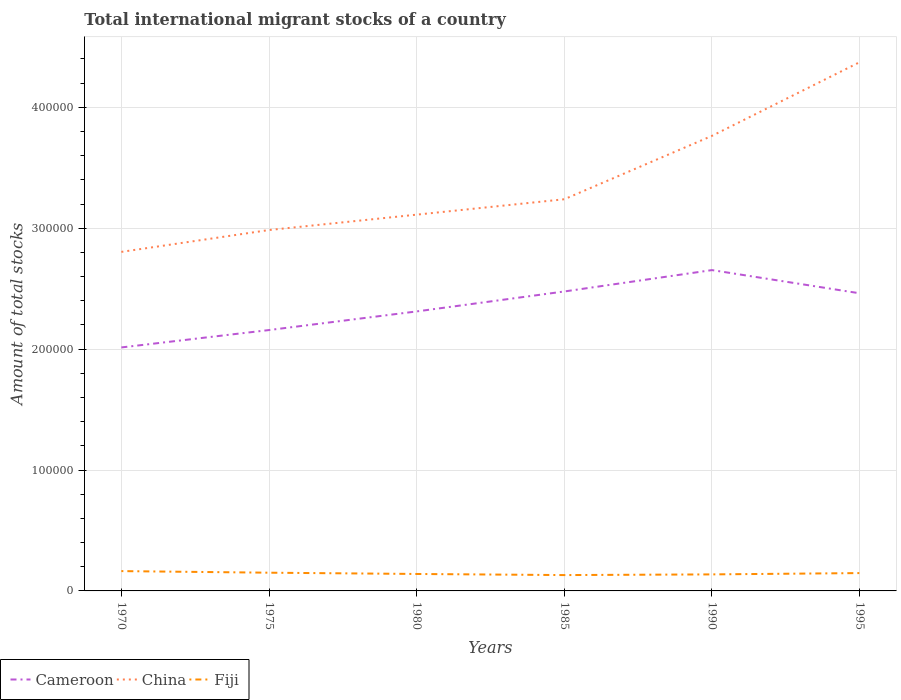How many different coloured lines are there?
Ensure brevity in your answer.  3. Across all years, what is the maximum amount of total stocks in in Cameroon?
Keep it short and to the point. 2.01e+05. In which year was the amount of total stocks in in Fiji maximum?
Your answer should be compact. 1985. What is the total amount of total stocks in in Cameroon in the graph?
Offer a terse response. 1490. What is the difference between the highest and the second highest amount of total stocks in in China?
Your answer should be compact. 1.57e+05. What is the difference between the highest and the lowest amount of total stocks in in Cameroon?
Give a very brief answer. 3. How many lines are there?
Your response must be concise. 3. How many years are there in the graph?
Your answer should be very brief. 6. Does the graph contain grids?
Make the answer very short. Yes. How are the legend labels stacked?
Provide a short and direct response. Horizontal. What is the title of the graph?
Give a very brief answer. Total international migrant stocks of a country. What is the label or title of the Y-axis?
Provide a succinct answer. Amount of total stocks. What is the Amount of total stocks of Cameroon in 1970?
Offer a very short reply. 2.01e+05. What is the Amount of total stocks of China in 1970?
Provide a short and direct response. 2.80e+05. What is the Amount of total stocks of Fiji in 1970?
Your answer should be compact. 1.64e+04. What is the Amount of total stocks of Cameroon in 1975?
Your response must be concise. 2.16e+05. What is the Amount of total stocks in China in 1975?
Give a very brief answer. 2.98e+05. What is the Amount of total stocks of Fiji in 1975?
Give a very brief answer. 1.51e+04. What is the Amount of total stocks of Cameroon in 1980?
Ensure brevity in your answer.  2.31e+05. What is the Amount of total stocks of China in 1980?
Offer a very short reply. 3.11e+05. What is the Amount of total stocks of Fiji in 1980?
Provide a short and direct response. 1.40e+04. What is the Amount of total stocks in Cameroon in 1985?
Your answer should be compact. 2.48e+05. What is the Amount of total stocks in China in 1985?
Your answer should be compact. 3.24e+05. What is the Amount of total stocks of Fiji in 1985?
Give a very brief answer. 1.31e+04. What is the Amount of total stocks of Cameroon in 1990?
Your answer should be very brief. 2.65e+05. What is the Amount of total stocks of China in 1990?
Provide a succinct answer. 3.76e+05. What is the Amount of total stocks in Fiji in 1990?
Ensure brevity in your answer.  1.37e+04. What is the Amount of total stocks of Cameroon in 1995?
Offer a very short reply. 2.46e+05. What is the Amount of total stocks in China in 1995?
Offer a terse response. 4.37e+05. What is the Amount of total stocks in Fiji in 1995?
Ensure brevity in your answer.  1.48e+04. Across all years, what is the maximum Amount of total stocks in Cameroon?
Ensure brevity in your answer.  2.65e+05. Across all years, what is the maximum Amount of total stocks in China?
Provide a short and direct response. 4.37e+05. Across all years, what is the maximum Amount of total stocks of Fiji?
Your answer should be compact. 1.64e+04. Across all years, what is the minimum Amount of total stocks in Cameroon?
Provide a succinct answer. 2.01e+05. Across all years, what is the minimum Amount of total stocks of China?
Give a very brief answer. 2.80e+05. Across all years, what is the minimum Amount of total stocks of Fiji?
Keep it short and to the point. 1.31e+04. What is the total Amount of total stocks in Cameroon in the graph?
Give a very brief answer. 1.41e+06. What is the total Amount of total stocks of China in the graph?
Ensure brevity in your answer.  2.03e+06. What is the total Amount of total stocks of Fiji in the graph?
Ensure brevity in your answer.  8.70e+04. What is the difference between the Amount of total stocks of Cameroon in 1970 and that in 1975?
Your response must be concise. -1.44e+04. What is the difference between the Amount of total stocks in China in 1970 and that in 1975?
Provide a short and direct response. -1.81e+04. What is the difference between the Amount of total stocks of Fiji in 1970 and that in 1975?
Offer a terse response. 1323. What is the difference between the Amount of total stocks of Cameroon in 1970 and that in 1980?
Your answer should be very brief. -2.98e+04. What is the difference between the Amount of total stocks of China in 1970 and that in 1980?
Provide a short and direct response. -3.08e+04. What is the difference between the Amount of total stocks in Fiji in 1970 and that in 1980?
Your response must be concise. 2369. What is the difference between the Amount of total stocks in Cameroon in 1970 and that in 1985?
Keep it short and to the point. -4.63e+04. What is the difference between the Amount of total stocks in China in 1970 and that in 1985?
Give a very brief answer. -4.35e+04. What is the difference between the Amount of total stocks of Fiji in 1970 and that in 1985?
Your response must be concise. 3291. What is the difference between the Amount of total stocks of Cameroon in 1970 and that in 1990?
Your response must be concise. -6.40e+04. What is the difference between the Amount of total stocks of China in 1970 and that in 1990?
Your response must be concise. -9.60e+04. What is the difference between the Amount of total stocks in Fiji in 1970 and that in 1990?
Give a very brief answer. 2723. What is the difference between the Amount of total stocks of Cameroon in 1970 and that in 1995?
Provide a succinct answer. -4.48e+04. What is the difference between the Amount of total stocks of China in 1970 and that in 1995?
Your answer should be very brief. -1.57e+05. What is the difference between the Amount of total stocks in Fiji in 1970 and that in 1995?
Your answer should be compact. 1642. What is the difference between the Amount of total stocks of Cameroon in 1975 and that in 1980?
Give a very brief answer. -1.54e+04. What is the difference between the Amount of total stocks in China in 1975 and that in 1980?
Offer a terse response. -1.27e+04. What is the difference between the Amount of total stocks of Fiji in 1975 and that in 1980?
Make the answer very short. 1046. What is the difference between the Amount of total stocks in Cameroon in 1975 and that in 1985?
Provide a succinct answer. -3.19e+04. What is the difference between the Amount of total stocks of China in 1975 and that in 1985?
Offer a terse response. -2.55e+04. What is the difference between the Amount of total stocks in Fiji in 1975 and that in 1985?
Your response must be concise. 1968. What is the difference between the Amount of total stocks in Cameroon in 1975 and that in 1990?
Your answer should be compact. -4.96e+04. What is the difference between the Amount of total stocks of China in 1975 and that in 1990?
Your answer should be very brief. -7.79e+04. What is the difference between the Amount of total stocks in Fiji in 1975 and that in 1990?
Provide a short and direct response. 1400. What is the difference between the Amount of total stocks in Cameroon in 1975 and that in 1995?
Offer a terse response. -3.04e+04. What is the difference between the Amount of total stocks of China in 1975 and that in 1995?
Your answer should be very brief. -1.39e+05. What is the difference between the Amount of total stocks of Fiji in 1975 and that in 1995?
Offer a very short reply. 319. What is the difference between the Amount of total stocks of Cameroon in 1980 and that in 1985?
Provide a short and direct response. -1.65e+04. What is the difference between the Amount of total stocks in China in 1980 and that in 1985?
Offer a terse response. -1.27e+04. What is the difference between the Amount of total stocks in Fiji in 1980 and that in 1985?
Ensure brevity in your answer.  922. What is the difference between the Amount of total stocks in Cameroon in 1980 and that in 1990?
Provide a succinct answer. -3.42e+04. What is the difference between the Amount of total stocks in China in 1980 and that in 1990?
Provide a short and direct response. -6.52e+04. What is the difference between the Amount of total stocks in Fiji in 1980 and that in 1990?
Your response must be concise. 354. What is the difference between the Amount of total stocks of Cameroon in 1980 and that in 1995?
Offer a terse response. -1.50e+04. What is the difference between the Amount of total stocks of China in 1980 and that in 1995?
Provide a short and direct response. -1.26e+05. What is the difference between the Amount of total stocks of Fiji in 1980 and that in 1995?
Offer a very short reply. -727. What is the difference between the Amount of total stocks of Cameroon in 1985 and that in 1990?
Your answer should be compact. -1.77e+04. What is the difference between the Amount of total stocks of China in 1985 and that in 1990?
Your response must be concise. -5.24e+04. What is the difference between the Amount of total stocks in Fiji in 1985 and that in 1990?
Give a very brief answer. -568. What is the difference between the Amount of total stocks of Cameroon in 1985 and that in 1995?
Your answer should be compact. 1490. What is the difference between the Amount of total stocks in China in 1985 and that in 1995?
Offer a very short reply. -1.13e+05. What is the difference between the Amount of total stocks of Fiji in 1985 and that in 1995?
Your answer should be very brief. -1649. What is the difference between the Amount of total stocks in Cameroon in 1990 and that in 1995?
Your response must be concise. 1.92e+04. What is the difference between the Amount of total stocks of China in 1990 and that in 1995?
Provide a succinct answer. -6.09e+04. What is the difference between the Amount of total stocks in Fiji in 1990 and that in 1995?
Offer a very short reply. -1081. What is the difference between the Amount of total stocks in Cameroon in 1970 and the Amount of total stocks in China in 1975?
Your answer should be very brief. -9.71e+04. What is the difference between the Amount of total stocks of Cameroon in 1970 and the Amount of total stocks of Fiji in 1975?
Your response must be concise. 1.86e+05. What is the difference between the Amount of total stocks in China in 1970 and the Amount of total stocks in Fiji in 1975?
Your answer should be compact. 2.65e+05. What is the difference between the Amount of total stocks in Cameroon in 1970 and the Amount of total stocks in China in 1980?
Your answer should be compact. -1.10e+05. What is the difference between the Amount of total stocks of Cameroon in 1970 and the Amount of total stocks of Fiji in 1980?
Your answer should be compact. 1.87e+05. What is the difference between the Amount of total stocks in China in 1970 and the Amount of total stocks in Fiji in 1980?
Offer a terse response. 2.66e+05. What is the difference between the Amount of total stocks of Cameroon in 1970 and the Amount of total stocks of China in 1985?
Offer a very short reply. -1.23e+05. What is the difference between the Amount of total stocks of Cameroon in 1970 and the Amount of total stocks of Fiji in 1985?
Make the answer very short. 1.88e+05. What is the difference between the Amount of total stocks in China in 1970 and the Amount of total stocks in Fiji in 1985?
Keep it short and to the point. 2.67e+05. What is the difference between the Amount of total stocks in Cameroon in 1970 and the Amount of total stocks in China in 1990?
Ensure brevity in your answer.  -1.75e+05. What is the difference between the Amount of total stocks of Cameroon in 1970 and the Amount of total stocks of Fiji in 1990?
Your answer should be compact. 1.88e+05. What is the difference between the Amount of total stocks in China in 1970 and the Amount of total stocks in Fiji in 1990?
Your response must be concise. 2.67e+05. What is the difference between the Amount of total stocks in Cameroon in 1970 and the Amount of total stocks in China in 1995?
Your response must be concise. -2.36e+05. What is the difference between the Amount of total stocks of Cameroon in 1970 and the Amount of total stocks of Fiji in 1995?
Offer a very short reply. 1.87e+05. What is the difference between the Amount of total stocks in China in 1970 and the Amount of total stocks in Fiji in 1995?
Your response must be concise. 2.66e+05. What is the difference between the Amount of total stocks of Cameroon in 1975 and the Amount of total stocks of China in 1980?
Make the answer very short. -9.54e+04. What is the difference between the Amount of total stocks in Cameroon in 1975 and the Amount of total stocks in Fiji in 1980?
Your answer should be very brief. 2.02e+05. What is the difference between the Amount of total stocks of China in 1975 and the Amount of total stocks of Fiji in 1980?
Your answer should be very brief. 2.84e+05. What is the difference between the Amount of total stocks in Cameroon in 1975 and the Amount of total stocks in China in 1985?
Provide a succinct answer. -1.08e+05. What is the difference between the Amount of total stocks of Cameroon in 1975 and the Amount of total stocks of Fiji in 1985?
Your response must be concise. 2.03e+05. What is the difference between the Amount of total stocks in China in 1975 and the Amount of total stocks in Fiji in 1985?
Offer a very short reply. 2.85e+05. What is the difference between the Amount of total stocks in Cameroon in 1975 and the Amount of total stocks in China in 1990?
Offer a very short reply. -1.61e+05. What is the difference between the Amount of total stocks of Cameroon in 1975 and the Amount of total stocks of Fiji in 1990?
Offer a terse response. 2.02e+05. What is the difference between the Amount of total stocks in China in 1975 and the Amount of total stocks in Fiji in 1990?
Offer a very short reply. 2.85e+05. What is the difference between the Amount of total stocks of Cameroon in 1975 and the Amount of total stocks of China in 1995?
Keep it short and to the point. -2.22e+05. What is the difference between the Amount of total stocks of Cameroon in 1975 and the Amount of total stocks of Fiji in 1995?
Make the answer very short. 2.01e+05. What is the difference between the Amount of total stocks of China in 1975 and the Amount of total stocks of Fiji in 1995?
Keep it short and to the point. 2.84e+05. What is the difference between the Amount of total stocks in Cameroon in 1980 and the Amount of total stocks in China in 1985?
Your answer should be compact. -9.28e+04. What is the difference between the Amount of total stocks of Cameroon in 1980 and the Amount of total stocks of Fiji in 1985?
Your response must be concise. 2.18e+05. What is the difference between the Amount of total stocks of China in 1980 and the Amount of total stocks of Fiji in 1985?
Ensure brevity in your answer.  2.98e+05. What is the difference between the Amount of total stocks of Cameroon in 1980 and the Amount of total stocks of China in 1990?
Your answer should be very brief. -1.45e+05. What is the difference between the Amount of total stocks of Cameroon in 1980 and the Amount of total stocks of Fiji in 1990?
Ensure brevity in your answer.  2.17e+05. What is the difference between the Amount of total stocks in China in 1980 and the Amount of total stocks in Fiji in 1990?
Offer a terse response. 2.98e+05. What is the difference between the Amount of total stocks in Cameroon in 1980 and the Amount of total stocks in China in 1995?
Offer a very short reply. -2.06e+05. What is the difference between the Amount of total stocks of Cameroon in 1980 and the Amount of total stocks of Fiji in 1995?
Ensure brevity in your answer.  2.16e+05. What is the difference between the Amount of total stocks in China in 1980 and the Amount of total stocks in Fiji in 1995?
Your answer should be compact. 2.96e+05. What is the difference between the Amount of total stocks of Cameroon in 1985 and the Amount of total stocks of China in 1990?
Make the answer very short. -1.29e+05. What is the difference between the Amount of total stocks of Cameroon in 1985 and the Amount of total stocks of Fiji in 1990?
Keep it short and to the point. 2.34e+05. What is the difference between the Amount of total stocks in China in 1985 and the Amount of total stocks in Fiji in 1990?
Your response must be concise. 3.10e+05. What is the difference between the Amount of total stocks in Cameroon in 1985 and the Amount of total stocks in China in 1995?
Your response must be concise. -1.90e+05. What is the difference between the Amount of total stocks in Cameroon in 1985 and the Amount of total stocks in Fiji in 1995?
Offer a terse response. 2.33e+05. What is the difference between the Amount of total stocks in China in 1985 and the Amount of total stocks in Fiji in 1995?
Keep it short and to the point. 3.09e+05. What is the difference between the Amount of total stocks of Cameroon in 1990 and the Amount of total stocks of China in 1995?
Ensure brevity in your answer.  -1.72e+05. What is the difference between the Amount of total stocks of Cameroon in 1990 and the Amount of total stocks of Fiji in 1995?
Keep it short and to the point. 2.51e+05. What is the difference between the Amount of total stocks of China in 1990 and the Amount of total stocks of Fiji in 1995?
Ensure brevity in your answer.  3.62e+05. What is the average Amount of total stocks of Cameroon per year?
Offer a terse response. 2.35e+05. What is the average Amount of total stocks of China per year?
Keep it short and to the point. 3.38e+05. What is the average Amount of total stocks in Fiji per year?
Give a very brief answer. 1.45e+04. In the year 1970, what is the difference between the Amount of total stocks in Cameroon and Amount of total stocks in China?
Your answer should be compact. -7.90e+04. In the year 1970, what is the difference between the Amount of total stocks in Cameroon and Amount of total stocks in Fiji?
Provide a succinct answer. 1.85e+05. In the year 1970, what is the difference between the Amount of total stocks of China and Amount of total stocks of Fiji?
Give a very brief answer. 2.64e+05. In the year 1975, what is the difference between the Amount of total stocks of Cameroon and Amount of total stocks of China?
Ensure brevity in your answer.  -8.27e+04. In the year 1975, what is the difference between the Amount of total stocks in Cameroon and Amount of total stocks in Fiji?
Offer a very short reply. 2.01e+05. In the year 1975, what is the difference between the Amount of total stocks of China and Amount of total stocks of Fiji?
Your response must be concise. 2.83e+05. In the year 1980, what is the difference between the Amount of total stocks of Cameroon and Amount of total stocks of China?
Your answer should be compact. -8.00e+04. In the year 1980, what is the difference between the Amount of total stocks in Cameroon and Amount of total stocks in Fiji?
Give a very brief answer. 2.17e+05. In the year 1980, what is the difference between the Amount of total stocks in China and Amount of total stocks in Fiji?
Make the answer very short. 2.97e+05. In the year 1985, what is the difference between the Amount of total stocks in Cameroon and Amount of total stocks in China?
Make the answer very short. -7.63e+04. In the year 1985, what is the difference between the Amount of total stocks of Cameroon and Amount of total stocks of Fiji?
Your answer should be compact. 2.35e+05. In the year 1985, what is the difference between the Amount of total stocks in China and Amount of total stocks in Fiji?
Provide a short and direct response. 3.11e+05. In the year 1990, what is the difference between the Amount of total stocks in Cameroon and Amount of total stocks in China?
Your response must be concise. -1.11e+05. In the year 1990, what is the difference between the Amount of total stocks in Cameroon and Amount of total stocks in Fiji?
Your answer should be compact. 2.52e+05. In the year 1990, what is the difference between the Amount of total stocks of China and Amount of total stocks of Fiji?
Offer a terse response. 3.63e+05. In the year 1995, what is the difference between the Amount of total stocks in Cameroon and Amount of total stocks in China?
Make the answer very short. -1.91e+05. In the year 1995, what is the difference between the Amount of total stocks of Cameroon and Amount of total stocks of Fiji?
Give a very brief answer. 2.31e+05. In the year 1995, what is the difference between the Amount of total stocks of China and Amount of total stocks of Fiji?
Your answer should be compact. 4.23e+05. What is the ratio of the Amount of total stocks in Cameroon in 1970 to that in 1975?
Your response must be concise. 0.93. What is the ratio of the Amount of total stocks of China in 1970 to that in 1975?
Make the answer very short. 0.94. What is the ratio of the Amount of total stocks of Fiji in 1970 to that in 1975?
Your response must be concise. 1.09. What is the ratio of the Amount of total stocks in Cameroon in 1970 to that in 1980?
Make the answer very short. 0.87. What is the ratio of the Amount of total stocks of China in 1970 to that in 1980?
Ensure brevity in your answer.  0.9. What is the ratio of the Amount of total stocks in Fiji in 1970 to that in 1980?
Offer a very short reply. 1.17. What is the ratio of the Amount of total stocks in Cameroon in 1970 to that in 1985?
Your response must be concise. 0.81. What is the ratio of the Amount of total stocks in China in 1970 to that in 1985?
Provide a succinct answer. 0.87. What is the ratio of the Amount of total stocks of Fiji in 1970 to that in 1985?
Your answer should be compact. 1.25. What is the ratio of the Amount of total stocks of Cameroon in 1970 to that in 1990?
Provide a short and direct response. 0.76. What is the ratio of the Amount of total stocks in China in 1970 to that in 1990?
Keep it short and to the point. 0.74. What is the ratio of the Amount of total stocks in Fiji in 1970 to that in 1990?
Your response must be concise. 1.2. What is the ratio of the Amount of total stocks of Cameroon in 1970 to that in 1995?
Your answer should be very brief. 0.82. What is the ratio of the Amount of total stocks of China in 1970 to that in 1995?
Ensure brevity in your answer.  0.64. What is the ratio of the Amount of total stocks of Fiji in 1970 to that in 1995?
Give a very brief answer. 1.11. What is the ratio of the Amount of total stocks of Cameroon in 1975 to that in 1980?
Offer a terse response. 0.93. What is the ratio of the Amount of total stocks of China in 1975 to that in 1980?
Your answer should be compact. 0.96. What is the ratio of the Amount of total stocks in Fiji in 1975 to that in 1980?
Ensure brevity in your answer.  1.07. What is the ratio of the Amount of total stocks of Cameroon in 1975 to that in 1985?
Make the answer very short. 0.87. What is the ratio of the Amount of total stocks in China in 1975 to that in 1985?
Make the answer very short. 0.92. What is the ratio of the Amount of total stocks in Fiji in 1975 to that in 1985?
Ensure brevity in your answer.  1.15. What is the ratio of the Amount of total stocks in Cameroon in 1975 to that in 1990?
Provide a short and direct response. 0.81. What is the ratio of the Amount of total stocks in China in 1975 to that in 1990?
Give a very brief answer. 0.79. What is the ratio of the Amount of total stocks in Fiji in 1975 to that in 1990?
Your answer should be very brief. 1.1. What is the ratio of the Amount of total stocks in Cameroon in 1975 to that in 1995?
Make the answer very short. 0.88. What is the ratio of the Amount of total stocks in China in 1975 to that in 1995?
Offer a terse response. 0.68. What is the ratio of the Amount of total stocks of Fiji in 1975 to that in 1995?
Offer a very short reply. 1.02. What is the ratio of the Amount of total stocks in Cameroon in 1980 to that in 1985?
Give a very brief answer. 0.93. What is the ratio of the Amount of total stocks of China in 1980 to that in 1985?
Make the answer very short. 0.96. What is the ratio of the Amount of total stocks of Fiji in 1980 to that in 1985?
Your answer should be compact. 1.07. What is the ratio of the Amount of total stocks in Cameroon in 1980 to that in 1990?
Provide a short and direct response. 0.87. What is the ratio of the Amount of total stocks of China in 1980 to that in 1990?
Provide a succinct answer. 0.83. What is the ratio of the Amount of total stocks of Fiji in 1980 to that in 1990?
Your response must be concise. 1.03. What is the ratio of the Amount of total stocks of Cameroon in 1980 to that in 1995?
Your answer should be very brief. 0.94. What is the ratio of the Amount of total stocks in China in 1980 to that in 1995?
Keep it short and to the point. 0.71. What is the ratio of the Amount of total stocks in Fiji in 1980 to that in 1995?
Provide a succinct answer. 0.95. What is the ratio of the Amount of total stocks in Cameroon in 1985 to that in 1990?
Your answer should be compact. 0.93. What is the ratio of the Amount of total stocks of China in 1985 to that in 1990?
Offer a terse response. 0.86. What is the ratio of the Amount of total stocks of Fiji in 1985 to that in 1990?
Ensure brevity in your answer.  0.96. What is the ratio of the Amount of total stocks in China in 1985 to that in 1995?
Your response must be concise. 0.74. What is the ratio of the Amount of total stocks in Fiji in 1985 to that in 1995?
Keep it short and to the point. 0.89. What is the ratio of the Amount of total stocks in Cameroon in 1990 to that in 1995?
Ensure brevity in your answer.  1.08. What is the ratio of the Amount of total stocks in China in 1990 to that in 1995?
Provide a succinct answer. 0.86. What is the ratio of the Amount of total stocks of Fiji in 1990 to that in 1995?
Ensure brevity in your answer.  0.93. What is the difference between the highest and the second highest Amount of total stocks in Cameroon?
Your answer should be very brief. 1.77e+04. What is the difference between the highest and the second highest Amount of total stocks in China?
Provide a succinct answer. 6.09e+04. What is the difference between the highest and the second highest Amount of total stocks of Fiji?
Keep it short and to the point. 1323. What is the difference between the highest and the lowest Amount of total stocks in Cameroon?
Offer a terse response. 6.40e+04. What is the difference between the highest and the lowest Amount of total stocks in China?
Make the answer very short. 1.57e+05. What is the difference between the highest and the lowest Amount of total stocks of Fiji?
Provide a succinct answer. 3291. 